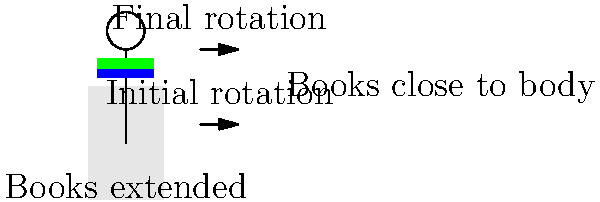As a book club president, you decide to demonstrate the concept of conservation of angular momentum using a swivel chair and some books. If you start spinning in the chair with your arms extended while holding books, and then bring the books close to your body, how will your angular velocity change? Explain the physics behind this phenomenon and relate it to how you might use this principle to engage your book club members in a unique discussion about physics in literature. Let's break this down step-by-step:

1. Initial state: You're spinning in the chair with arms extended, holding books. Your moment of inertia (I) is large due to the mass distribution away from the axis of rotation.

2. Conservation of angular momentum: The law states that in the absence of external torques, angular momentum (L) is conserved. Mathematically, this is expressed as:

   $$L = I\omega = \text{constant}$$

   Where I is the moment of inertia and ω is the angular velocity.

3. Changing configuration: When you bring the books close to your body, you're decreasing your moment of inertia (I). The mass is now closer to the axis of rotation.

4. Conservation in action: Since L must remain constant, and I has decreased, ω must increase to maintain the equality:

   $$I_1\omega_1 = I_2\omega_2$$

   Where subscript 1 represents the initial state and 2 the final state.

5. Result: Your angular velocity increases as you bring the books closer to your body.

6. Book club application: This demonstration can be used to discuss how authors use physics principles in their narratives. For example, you could relate this to scenes in science fiction novels where characters manipulate their rotation in space, or how understanding of physical laws influences an author's world-building in fantasy or sci-fi genres.

7. Engaging discussion: You could ask club members to identify instances of conservation laws in literature, encouraging them to think critically about the scientific accuracy in the books they read.
Answer: Angular velocity increases as books are brought closer to body, due to conservation of angular momentum. 